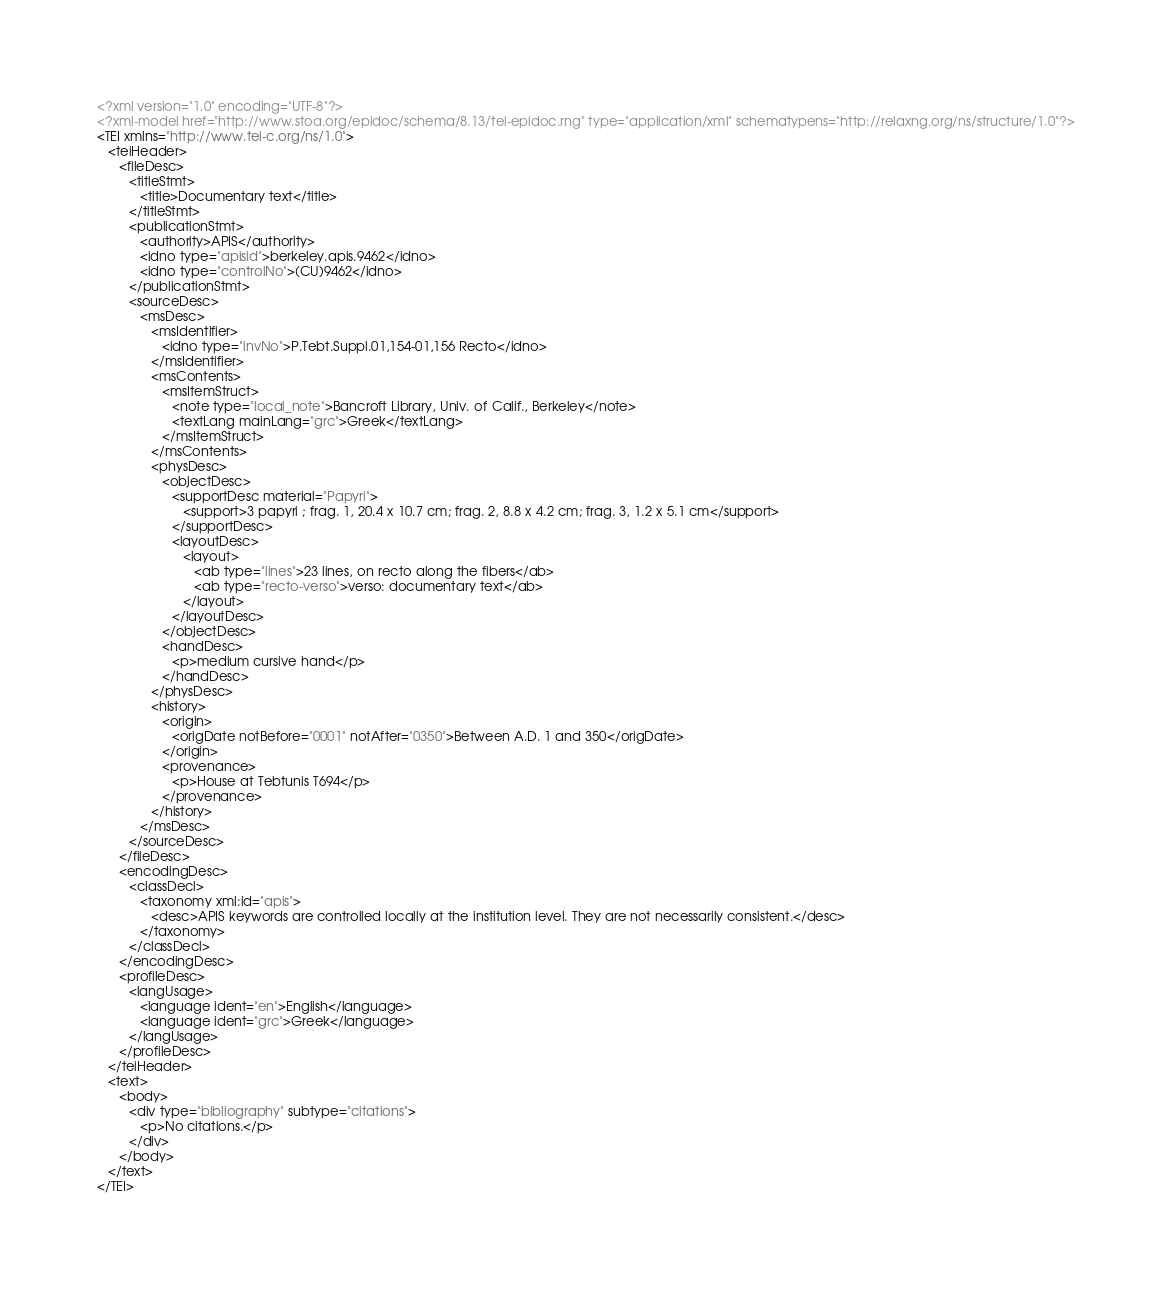Convert code to text. <code><loc_0><loc_0><loc_500><loc_500><_XML_><?xml version="1.0" encoding="UTF-8"?>
<?xml-model href="http://www.stoa.org/epidoc/schema/8.13/tei-epidoc.rng" type="application/xml" schematypens="http://relaxng.org/ns/structure/1.0"?>
<TEI xmlns="http://www.tei-c.org/ns/1.0">
   <teiHeader>
      <fileDesc>
         <titleStmt>
            <title>Documentary text</title>
         </titleStmt>
         <publicationStmt>
            <authority>APIS</authority>
            <idno type="apisid">berkeley.apis.9462</idno>
            <idno type="controlNo">(CU)9462</idno>
         </publicationStmt>
         <sourceDesc>
            <msDesc>
               <msIdentifier>
                  <idno type="invNo">P.Tebt.Suppl.01,154-01,156 Recto</idno>
               </msIdentifier>
               <msContents>
                  <msItemStruct>
                     <note type="local_note">Bancroft Library, Univ. of Calif., Berkeley</note>
                     <textLang mainLang="grc">Greek</textLang>
                  </msItemStruct>
               </msContents>
               <physDesc>
                  <objectDesc>
                     <supportDesc material="Papyri">
                        <support>3 papyri ; frag. 1, 20.4 x 10.7 cm; frag. 2, 8.8 x 4.2 cm; frag. 3, 1.2 x 5.1 cm</support>
                     </supportDesc>
                     <layoutDesc>
                        <layout>
                           <ab type="lines">23 lines, on recto along the fibers</ab>
                           <ab type="recto-verso">verso: documentary text</ab>
                        </layout>
                     </layoutDesc>
                  </objectDesc>
                  <handDesc>
                     <p>medium cursive hand</p>
                  </handDesc>
               </physDesc>
               <history>
                  <origin>
                     <origDate notBefore="0001" notAfter="0350">Between A.D. 1 and 350</origDate>
                  </origin>
                  <provenance>
                     <p>House at Tebtunis T694</p>
                  </provenance>
               </history>
            </msDesc>
         </sourceDesc>
      </fileDesc>
      <encodingDesc>
         <classDecl>
            <taxonomy xml:id="apis">
               <desc>APIS keywords are controlled locally at the institution level. They are not necessarily consistent.</desc>
            </taxonomy>
         </classDecl>
      </encodingDesc>
      <profileDesc>
         <langUsage>
            <language ident="en">English</language>
            <language ident="grc">Greek</language>
         </langUsage>
      </profileDesc>
   </teiHeader>
   <text>
      <body>
         <div type="bibliography" subtype="citations">
            <p>No citations.</p>
         </div>
      </body>
   </text>
</TEI></code> 